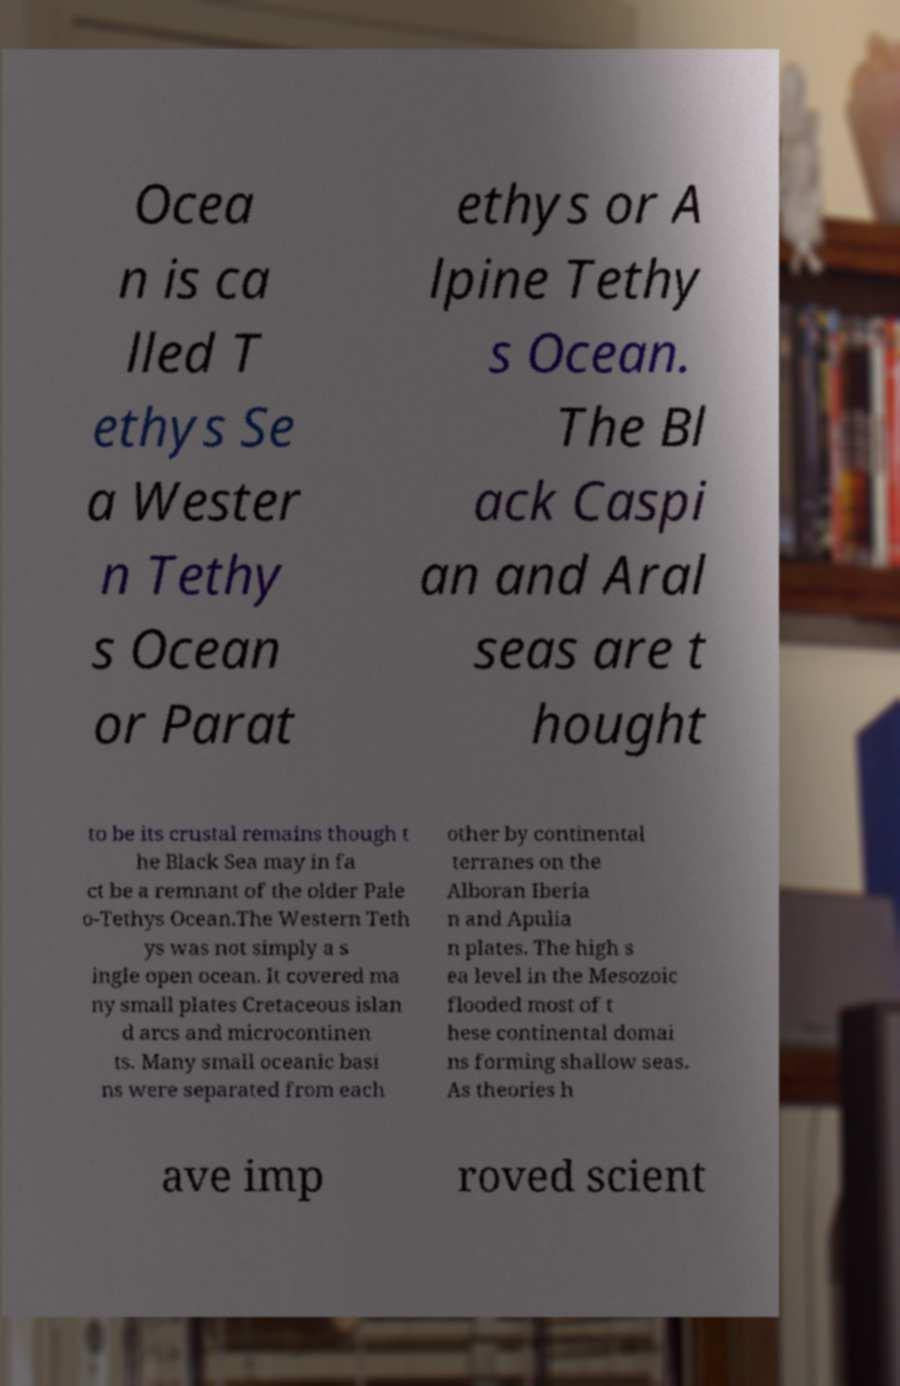There's text embedded in this image that I need extracted. Can you transcribe it verbatim? Ocea n is ca lled T ethys Se a Wester n Tethy s Ocean or Parat ethys or A lpine Tethy s Ocean. The Bl ack Caspi an and Aral seas are t hought to be its crustal remains though t he Black Sea may in fa ct be a remnant of the older Pale o-Tethys Ocean.The Western Teth ys was not simply a s ingle open ocean. It covered ma ny small plates Cretaceous islan d arcs and microcontinen ts. Many small oceanic basi ns were separated from each other by continental terranes on the Alboran Iberia n and Apulia n plates. The high s ea level in the Mesozoic flooded most of t hese continental domai ns forming shallow seas. As theories h ave imp roved scient 